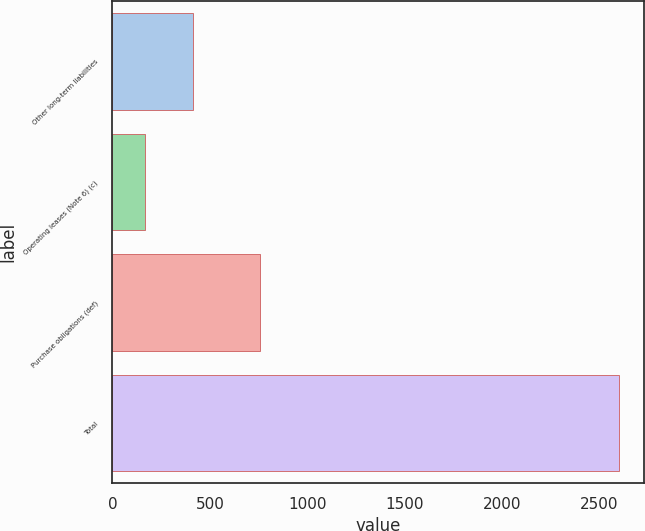Convert chart to OTSL. <chart><loc_0><loc_0><loc_500><loc_500><bar_chart><fcel>Other long-term liabilities<fcel>Operating leases (Note 6) (c)<fcel>Purchase obligations (def)<fcel>Total<nl><fcel>412.1<fcel>169<fcel>759<fcel>2600<nl></chart> 